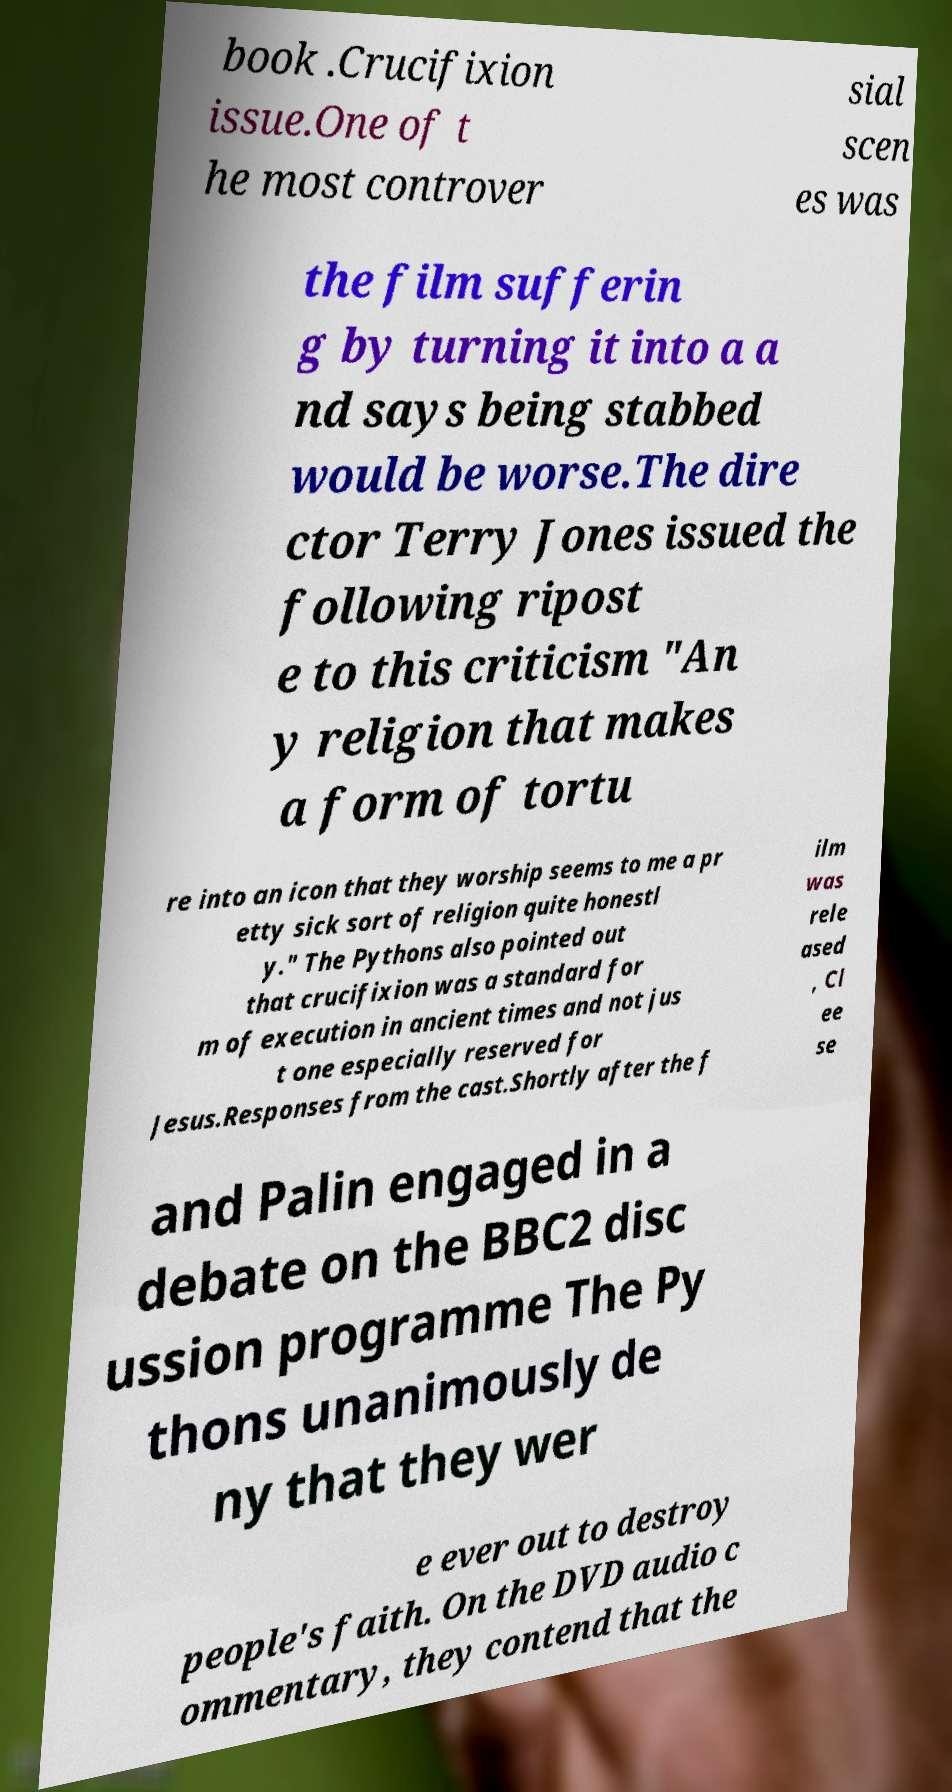Could you extract and type out the text from this image? book .Crucifixion issue.One of t he most controver sial scen es was the film sufferin g by turning it into a a nd says being stabbed would be worse.The dire ctor Terry Jones issued the following ripost e to this criticism "An y religion that makes a form of tortu re into an icon that they worship seems to me a pr etty sick sort of religion quite honestl y." The Pythons also pointed out that crucifixion was a standard for m of execution in ancient times and not jus t one especially reserved for Jesus.Responses from the cast.Shortly after the f ilm was rele ased , Cl ee se and Palin engaged in a debate on the BBC2 disc ussion programme The Py thons unanimously de ny that they wer e ever out to destroy people's faith. On the DVD audio c ommentary, they contend that the 